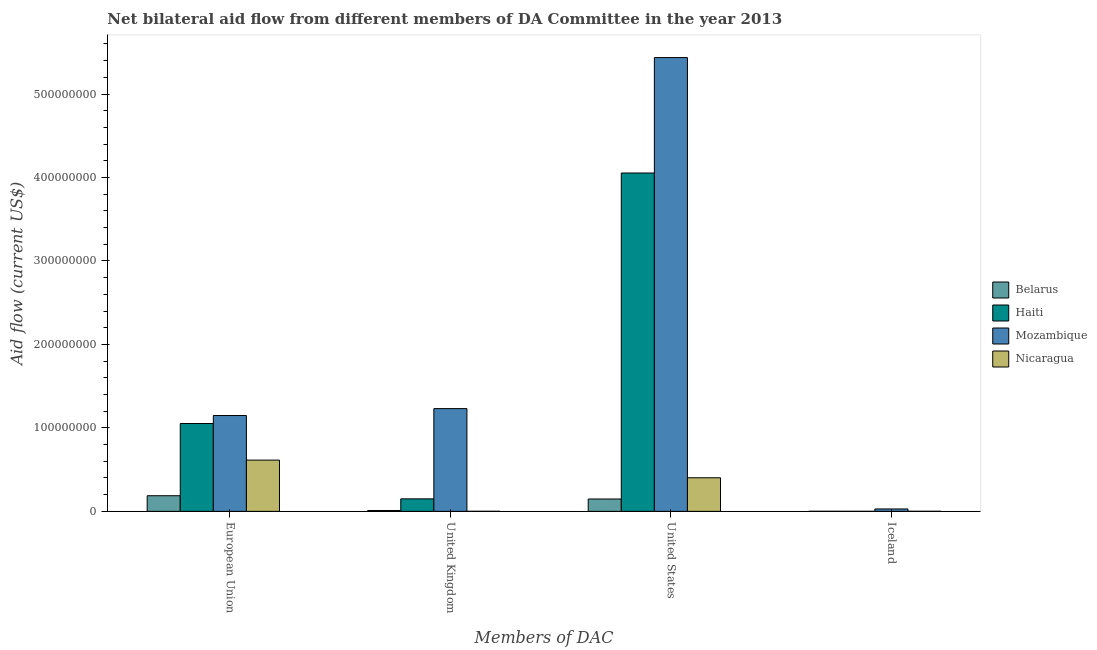How many different coloured bars are there?
Offer a very short reply. 4. How many groups of bars are there?
Your response must be concise. 4. Are the number of bars per tick equal to the number of legend labels?
Ensure brevity in your answer.  Yes. Are the number of bars on each tick of the X-axis equal?
Provide a succinct answer. Yes. How many bars are there on the 1st tick from the left?
Provide a short and direct response. 4. What is the label of the 4th group of bars from the left?
Your response must be concise. Iceland. What is the amount of aid given by iceland in Belarus?
Keep it short and to the point. 1.10e+05. Across all countries, what is the maximum amount of aid given by eu?
Offer a terse response. 1.15e+08. Across all countries, what is the minimum amount of aid given by iceland?
Keep it short and to the point. 7.00e+04. In which country was the amount of aid given by us maximum?
Your response must be concise. Mozambique. In which country was the amount of aid given by uk minimum?
Make the answer very short. Nicaragua. What is the total amount of aid given by eu in the graph?
Provide a short and direct response. 3.00e+08. What is the difference between the amount of aid given by eu in Nicaragua and that in Haiti?
Give a very brief answer. -4.39e+07. What is the difference between the amount of aid given by iceland in Haiti and the amount of aid given by eu in Belarus?
Make the answer very short. -1.87e+07. What is the average amount of aid given by iceland per country?
Your answer should be very brief. 7.85e+05. What is the difference between the amount of aid given by eu and amount of aid given by us in Nicaragua?
Offer a very short reply. 2.12e+07. What is the ratio of the amount of aid given by us in Belarus to that in Nicaragua?
Offer a terse response. 0.37. What is the difference between the highest and the second highest amount of aid given by uk?
Provide a succinct answer. 1.08e+08. What is the difference between the highest and the lowest amount of aid given by uk?
Your answer should be very brief. 1.23e+08. Is the sum of the amount of aid given by iceland in Mozambique and Haiti greater than the maximum amount of aid given by us across all countries?
Provide a succinct answer. No. What does the 4th bar from the left in European Union represents?
Provide a short and direct response. Nicaragua. What does the 1st bar from the right in United Kingdom represents?
Offer a very short reply. Nicaragua. Is it the case that in every country, the sum of the amount of aid given by eu and amount of aid given by uk is greater than the amount of aid given by us?
Your response must be concise. No. How many bars are there?
Your answer should be compact. 16. Are all the bars in the graph horizontal?
Offer a terse response. No. What is the difference between two consecutive major ticks on the Y-axis?
Your answer should be very brief. 1.00e+08. Are the values on the major ticks of Y-axis written in scientific E-notation?
Your response must be concise. No. Where does the legend appear in the graph?
Keep it short and to the point. Center right. What is the title of the graph?
Offer a terse response. Net bilateral aid flow from different members of DA Committee in the year 2013. What is the label or title of the X-axis?
Offer a very short reply. Members of DAC. What is the Aid flow (current US$) in Belarus in European Union?
Make the answer very short. 1.87e+07. What is the Aid flow (current US$) of Haiti in European Union?
Offer a terse response. 1.05e+08. What is the Aid flow (current US$) of Mozambique in European Union?
Ensure brevity in your answer.  1.15e+08. What is the Aid flow (current US$) in Nicaragua in European Union?
Offer a very short reply. 6.14e+07. What is the Aid flow (current US$) of Belarus in United Kingdom?
Offer a very short reply. 1.02e+06. What is the Aid flow (current US$) of Haiti in United Kingdom?
Provide a short and direct response. 1.50e+07. What is the Aid flow (current US$) of Mozambique in United Kingdom?
Keep it short and to the point. 1.23e+08. What is the Aid flow (current US$) of Nicaragua in United Kingdom?
Give a very brief answer. 8.00e+04. What is the Aid flow (current US$) of Belarus in United States?
Make the answer very short. 1.48e+07. What is the Aid flow (current US$) of Haiti in United States?
Keep it short and to the point. 4.05e+08. What is the Aid flow (current US$) in Mozambique in United States?
Give a very brief answer. 5.44e+08. What is the Aid flow (current US$) in Nicaragua in United States?
Offer a terse response. 4.02e+07. What is the Aid flow (current US$) of Mozambique in Iceland?
Keep it short and to the point. 2.88e+06. What is the Aid flow (current US$) of Nicaragua in Iceland?
Offer a terse response. 8.00e+04. Across all Members of DAC, what is the maximum Aid flow (current US$) of Belarus?
Provide a short and direct response. 1.87e+07. Across all Members of DAC, what is the maximum Aid flow (current US$) of Haiti?
Ensure brevity in your answer.  4.05e+08. Across all Members of DAC, what is the maximum Aid flow (current US$) in Mozambique?
Provide a succinct answer. 5.44e+08. Across all Members of DAC, what is the maximum Aid flow (current US$) in Nicaragua?
Offer a very short reply. 6.14e+07. Across all Members of DAC, what is the minimum Aid flow (current US$) of Haiti?
Offer a terse response. 7.00e+04. Across all Members of DAC, what is the minimum Aid flow (current US$) of Mozambique?
Ensure brevity in your answer.  2.88e+06. Across all Members of DAC, what is the minimum Aid flow (current US$) of Nicaragua?
Offer a very short reply. 8.00e+04. What is the total Aid flow (current US$) in Belarus in the graph?
Offer a terse response. 3.47e+07. What is the total Aid flow (current US$) in Haiti in the graph?
Offer a terse response. 5.26e+08. What is the total Aid flow (current US$) in Mozambique in the graph?
Keep it short and to the point. 7.84e+08. What is the total Aid flow (current US$) of Nicaragua in the graph?
Offer a terse response. 1.02e+08. What is the difference between the Aid flow (current US$) in Belarus in European Union and that in United Kingdom?
Keep it short and to the point. 1.77e+07. What is the difference between the Aid flow (current US$) of Haiti in European Union and that in United Kingdom?
Your answer should be compact. 9.03e+07. What is the difference between the Aid flow (current US$) in Mozambique in European Union and that in United Kingdom?
Offer a very short reply. -8.27e+06. What is the difference between the Aid flow (current US$) in Nicaragua in European Union and that in United Kingdom?
Provide a short and direct response. 6.13e+07. What is the difference between the Aid flow (current US$) of Belarus in European Union and that in United States?
Keep it short and to the point. 3.91e+06. What is the difference between the Aid flow (current US$) of Haiti in European Union and that in United States?
Provide a succinct answer. -3.00e+08. What is the difference between the Aid flow (current US$) of Mozambique in European Union and that in United States?
Provide a short and direct response. -4.29e+08. What is the difference between the Aid flow (current US$) in Nicaragua in European Union and that in United States?
Ensure brevity in your answer.  2.12e+07. What is the difference between the Aid flow (current US$) of Belarus in European Union and that in Iceland?
Your answer should be very brief. 1.86e+07. What is the difference between the Aid flow (current US$) in Haiti in European Union and that in Iceland?
Your answer should be compact. 1.05e+08. What is the difference between the Aid flow (current US$) in Mozambique in European Union and that in Iceland?
Offer a very short reply. 1.12e+08. What is the difference between the Aid flow (current US$) of Nicaragua in European Union and that in Iceland?
Provide a short and direct response. 6.13e+07. What is the difference between the Aid flow (current US$) of Belarus in United Kingdom and that in United States?
Your response must be concise. -1.38e+07. What is the difference between the Aid flow (current US$) of Haiti in United Kingdom and that in United States?
Make the answer very short. -3.90e+08. What is the difference between the Aid flow (current US$) in Mozambique in United Kingdom and that in United States?
Give a very brief answer. -4.21e+08. What is the difference between the Aid flow (current US$) of Nicaragua in United Kingdom and that in United States?
Ensure brevity in your answer.  -4.02e+07. What is the difference between the Aid flow (current US$) in Belarus in United Kingdom and that in Iceland?
Provide a short and direct response. 9.10e+05. What is the difference between the Aid flow (current US$) in Haiti in United Kingdom and that in Iceland?
Ensure brevity in your answer.  1.49e+07. What is the difference between the Aid flow (current US$) in Mozambique in United Kingdom and that in Iceland?
Ensure brevity in your answer.  1.20e+08. What is the difference between the Aid flow (current US$) in Nicaragua in United Kingdom and that in Iceland?
Your answer should be very brief. 0. What is the difference between the Aid flow (current US$) in Belarus in United States and that in Iceland?
Your answer should be compact. 1.47e+07. What is the difference between the Aid flow (current US$) in Haiti in United States and that in Iceland?
Offer a terse response. 4.05e+08. What is the difference between the Aid flow (current US$) in Mozambique in United States and that in Iceland?
Your response must be concise. 5.41e+08. What is the difference between the Aid flow (current US$) of Nicaragua in United States and that in Iceland?
Your answer should be very brief. 4.02e+07. What is the difference between the Aid flow (current US$) in Belarus in European Union and the Aid flow (current US$) in Haiti in United Kingdom?
Give a very brief answer. 3.74e+06. What is the difference between the Aid flow (current US$) of Belarus in European Union and the Aid flow (current US$) of Mozambique in United Kingdom?
Make the answer very short. -1.04e+08. What is the difference between the Aid flow (current US$) in Belarus in European Union and the Aid flow (current US$) in Nicaragua in United Kingdom?
Give a very brief answer. 1.86e+07. What is the difference between the Aid flow (current US$) in Haiti in European Union and the Aid flow (current US$) in Mozambique in United Kingdom?
Your answer should be compact. -1.78e+07. What is the difference between the Aid flow (current US$) of Haiti in European Union and the Aid flow (current US$) of Nicaragua in United Kingdom?
Keep it short and to the point. 1.05e+08. What is the difference between the Aid flow (current US$) of Mozambique in European Union and the Aid flow (current US$) of Nicaragua in United Kingdom?
Your answer should be very brief. 1.15e+08. What is the difference between the Aid flow (current US$) of Belarus in European Union and the Aid flow (current US$) of Haiti in United States?
Your answer should be very brief. -3.87e+08. What is the difference between the Aid flow (current US$) of Belarus in European Union and the Aid flow (current US$) of Mozambique in United States?
Your response must be concise. -5.25e+08. What is the difference between the Aid flow (current US$) in Belarus in European Union and the Aid flow (current US$) in Nicaragua in United States?
Provide a succinct answer. -2.15e+07. What is the difference between the Aid flow (current US$) of Haiti in European Union and the Aid flow (current US$) of Mozambique in United States?
Your response must be concise. -4.38e+08. What is the difference between the Aid flow (current US$) of Haiti in European Union and the Aid flow (current US$) of Nicaragua in United States?
Offer a terse response. 6.50e+07. What is the difference between the Aid flow (current US$) of Mozambique in European Union and the Aid flow (current US$) of Nicaragua in United States?
Provide a short and direct response. 7.46e+07. What is the difference between the Aid flow (current US$) in Belarus in European Union and the Aid flow (current US$) in Haiti in Iceland?
Keep it short and to the point. 1.87e+07. What is the difference between the Aid flow (current US$) in Belarus in European Union and the Aid flow (current US$) in Mozambique in Iceland?
Keep it short and to the point. 1.58e+07. What is the difference between the Aid flow (current US$) of Belarus in European Union and the Aid flow (current US$) of Nicaragua in Iceland?
Ensure brevity in your answer.  1.86e+07. What is the difference between the Aid flow (current US$) in Haiti in European Union and the Aid flow (current US$) in Mozambique in Iceland?
Your response must be concise. 1.02e+08. What is the difference between the Aid flow (current US$) in Haiti in European Union and the Aid flow (current US$) in Nicaragua in Iceland?
Give a very brief answer. 1.05e+08. What is the difference between the Aid flow (current US$) of Mozambique in European Union and the Aid flow (current US$) of Nicaragua in Iceland?
Keep it short and to the point. 1.15e+08. What is the difference between the Aid flow (current US$) of Belarus in United Kingdom and the Aid flow (current US$) of Haiti in United States?
Keep it short and to the point. -4.04e+08. What is the difference between the Aid flow (current US$) in Belarus in United Kingdom and the Aid flow (current US$) in Mozambique in United States?
Offer a very short reply. -5.43e+08. What is the difference between the Aid flow (current US$) in Belarus in United Kingdom and the Aid flow (current US$) in Nicaragua in United States?
Keep it short and to the point. -3.92e+07. What is the difference between the Aid flow (current US$) in Haiti in United Kingdom and the Aid flow (current US$) in Mozambique in United States?
Keep it short and to the point. -5.29e+08. What is the difference between the Aid flow (current US$) of Haiti in United Kingdom and the Aid flow (current US$) of Nicaragua in United States?
Keep it short and to the point. -2.52e+07. What is the difference between the Aid flow (current US$) of Mozambique in United Kingdom and the Aid flow (current US$) of Nicaragua in United States?
Make the answer very short. 8.29e+07. What is the difference between the Aid flow (current US$) in Belarus in United Kingdom and the Aid flow (current US$) in Haiti in Iceland?
Give a very brief answer. 9.50e+05. What is the difference between the Aid flow (current US$) in Belarus in United Kingdom and the Aid flow (current US$) in Mozambique in Iceland?
Your answer should be compact. -1.86e+06. What is the difference between the Aid flow (current US$) of Belarus in United Kingdom and the Aid flow (current US$) of Nicaragua in Iceland?
Your answer should be compact. 9.40e+05. What is the difference between the Aid flow (current US$) in Haiti in United Kingdom and the Aid flow (current US$) in Mozambique in Iceland?
Offer a terse response. 1.21e+07. What is the difference between the Aid flow (current US$) of Haiti in United Kingdom and the Aid flow (current US$) of Nicaragua in Iceland?
Your answer should be compact. 1.49e+07. What is the difference between the Aid flow (current US$) in Mozambique in United Kingdom and the Aid flow (current US$) in Nicaragua in Iceland?
Provide a succinct answer. 1.23e+08. What is the difference between the Aid flow (current US$) in Belarus in United States and the Aid flow (current US$) in Haiti in Iceland?
Your answer should be compact. 1.48e+07. What is the difference between the Aid flow (current US$) of Belarus in United States and the Aid flow (current US$) of Mozambique in Iceland?
Your response must be concise. 1.19e+07. What is the difference between the Aid flow (current US$) in Belarus in United States and the Aid flow (current US$) in Nicaragua in Iceland?
Keep it short and to the point. 1.47e+07. What is the difference between the Aid flow (current US$) in Haiti in United States and the Aid flow (current US$) in Mozambique in Iceland?
Your answer should be compact. 4.02e+08. What is the difference between the Aid flow (current US$) of Haiti in United States and the Aid flow (current US$) of Nicaragua in Iceland?
Give a very brief answer. 4.05e+08. What is the difference between the Aid flow (current US$) of Mozambique in United States and the Aid flow (current US$) of Nicaragua in Iceland?
Provide a short and direct response. 5.44e+08. What is the average Aid flow (current US$) of Belarus per Members of DAC?
Provide a succinct answer. 8.67e+06. What is the average Aid flow (current US$) of Haiti per Members of DAC?
Your answer should be compact. 1.31e+08. What is the average Aid flow (current US$) in Mozambique per Members of DAC?
Offer a very short reply. 1.96e+08. What is the average Aid flow (current US$) in Nicaragua per Members of DAC?
Provide a succinct answer. 2.55e+07. What is the difference between the Aid flow (current US$) in Belarus and Aid flow (current US$) in Haiti in European Union?
Your answer should be compact. -8.66e+07. What is the difference between the Aid flow (current US$) of Belarus and Aid flow (current US$) of Mozambique in European Union?
Your answer should be compact. -9.61e+07. What is the difference between the Aid flow (current US$) in Belarus and Aid flow (current US$) in Nicaragua in European Union?
Provide a succinct answer. -4.27e+07. What is the difference between the Aid flow (current US$) in Haiti and Aid flow (current US$) in Mozambique in European Union?
Your answer should be compact. -9.55e+06. What is the difference between the Aid flow (current US$) of Haiti and Aid flow (current US$) of Nicaragua in European Union?
Provide a short and direct response. 4.39e+07. What is the difference between the Aid flow (current US$) of Mozambique and Aid flow (current US$) of Nicaragua in European Union?
Ensure brevity in your answer.  5.34e+07. What is the difference between the Aid flow (current US$) in Belarus and Aid flow (current US$) in Haiti in United Kingdom?
Your answer should be compact. -1.40e+07. What is the difference between the Aid flow (current US$) of Belarus and Aid flow (current US$) of Mozambique in United Kingdom?
Give a very brief answer. -1.22e+08. What is the difference between the Aid flow (current US$) in Belarus and Aid flow (current US$) in Nicaragua in United Kingdom?
Your answer should be compact. 9.40e+05. What is the difference between the Aid flow (current US$) of Haiti and Aid flow (current US$) of Mozambique in United Kingdom?
Make the answer very short. -1.08e+08. What is the difference between the Aid flow (current US$) in Haiti and Aid flow (current US$) in Nicaragua in United Kingdom?
Your answer should be compact. 1.49e+07. What is the difference between the Aid flow (current US$) of Mozambique and Aid flow (current US$) of Nicaragua in United Kingdom?
Your answer should be compact. 1.23e+08. What is the difference between the Aid flow (current US$) of Belarus and Aid flow (current US$) of Haiti in United States?
Offer a very short reply. -3.91e+08. What is the difference between the Aid flow (current US$) of Belarus and Aid flow (current US$) of Mozambique in United States?
Provide a short and direct response. -5.29e+08. What is the difference between the Aid flow (current US$) in Belarus and Aid flow (current US$) in Nicaragua in United States?
Ensure brevity in your answer.  -2.54e+07. What is the difference between the Aid flow (current US$) in Haiti and Aid flow (current US$) in Mozambique in United States?
Your response must be concise. -1.38e+08. What is the difference between the Aid flow (current US$) of Haiti and Aid flow (current US$) of Nicaragua in United States?
Make the answer very short. 3.65e+08. What is the difference between the Aid flow (current US$) in Mozambique and Aid flow (current US$) in Nicaragua in United States?
Your answer should be very brief. 5.03e+08. What is the difference between the Aid flow (current US$) in Belarus and Aid flow (current US$) in Mozambique in Iceland?
Your answer should be very brief. -2.77e+06. What is the difference between the Aid flow (current US$) of Haiti and Aid flow (current US$) of Mozambique in Iceland?
Your answer should be very brief. -2.81e+06. What is the difference between the Aid flow (current US$) of Haiti and Aid flow (current US$) of Nicaragua in Iceland?
Your answer should be compact. -10000. What is the difference between the Aid flow (current US$) of Mozambique and Aid flow (current US$) of Nicaragua in Iceland?
Offer a very short reply. 2.80e+06. What is the ratio of the Aid flow (current US$) in Belarus in European Union to that in United Kingdom?
Give a very brief answer. 18.36. What is the ratio of the Aid flow (current US$) in Haiti in European Union to that in United Kingdom?
Your answer should be very brief. 7.02. What is the ratio of the Aid flow (current US$) in Mozambique in European Union to that in United Kingdom?
Give a very brief answer. 0.93. What is the ratio of the Aid flow (current US$) of Nicaragua in European Union to that in United Kingdom?
Your response must be concise. 767.62. What is the ratio of the Aid flow (current US$) of Belarus in European Union to that in United States?
Offer a very short reply. 1.26. What is the ratio of the Aid flow (current US$) of Haiti in European Union to that in United States?
Your answer should be very brief. 0.26. What is the ratio of the Aid flow (current US$) of Mozambique in European Union to that in United States?
Offer a very short reply. 0.21. What is the ratio of the Aid flow (current US$) of Nicaragua in European Union to that in United States?
Offer a terse response. 1.53. What is the ratio of the Aid flow (current US$) in Belarus in European Union to that in Iceland?
Keep it short and to the point. 170.27. What is the ratio of the Aid flow (current US$) in Haiti in European Union to that in Iceland?
Your answer should be compact. 1504. What is the ratio of the Aid flow (current US$) of Mozambique in European Union to that in Iceland?
Offer a very short reply. 39.87. What is the ratio of the Aid flow (current US$) of Nicaragua in European Union to that in Iceland?
Keep it short and to the point. 767.62. What is the ratio of the Aid flow (current US$) in Belarus in United Kingdom to that in United States?
Your answer should be compact. 0.07. What is the ratio of the Aid flow (current US$) in Haiti in United Kingdom to that in United States?
Give a very brief answer. 0.04. What is the ratio of the Aid flow (current US$) in Mozambique in United Kingdom to that in United States?
Your answer should be very brief. 0.23. What is the ratio of the Aid flow (current US$) in Nicaragua in United Kingdom to that in United States?
Make the answer very short. 0. What is the ratio of the Aid flow (current US$) in Belarus in United Kingdom to that in Iceland?
Give a very brief answer. 9.27. What is the ratio of the Aid flow (current US$) of Haiti in United Kingdom to that in Iceland?
Ensure brevity in your answer.  214.14. What is the ratio of the Aid flow (current US$) in Mozambique in United Kingdom to that in Iceland?
Your response must be concise. 42.74. What is the ratio of the Aid flow (current US$) of Belarus in United States to that in Iceland?
Your answer should be compact. 134.73. What is the ratio of the Aid flow (current US$) in Haiti in United States to that in Iceland?
Make the answer very short. 5791.14. What is the ratio of the Aid flow (current US$) in Mozambique in United States to that in Iceland?
Your answer should be compact. 188.78. What is the ratio of the Aid flow (current US$) of Nicaragua in United States to that in Iceland?
Make the answer very short. 503. What is the difference between the highest and the second highest Aid flow (current US$) in Belarus?
Offer a terse response. 3.91e+06. What is the difference between the highest and the second highest Aid flow (current US$) of Haiti?
Your response must be concise. 3.00e+08. What is the difference between the highest and the second highest Aid flow (current US$) of Mozambique?
Your answer should be very brief. 4.21e+08. What is the difference between the highest and the second highest Aid flow (current US$) of Nicaragua?
Offer a terse response. 2.12e+07. What is the difference between the highest and the lowest Aid flow (current US$) of Belarus?
Your answer should be compact. 1.86e+07. What is the difference between the highest and the lowest Aid flow (current US$) in Haiti?
Offer a very short reply. 4.05e+08. What is the difference between the highest and the lowest Aid flow (current US$) in Mozambique?
Provide a short and direct response. 5.41e+08. What is the difference between the highest and the lowest Aid flow (current US$) of Nicaragua?
Your response must be concise. 6.13e+07. 